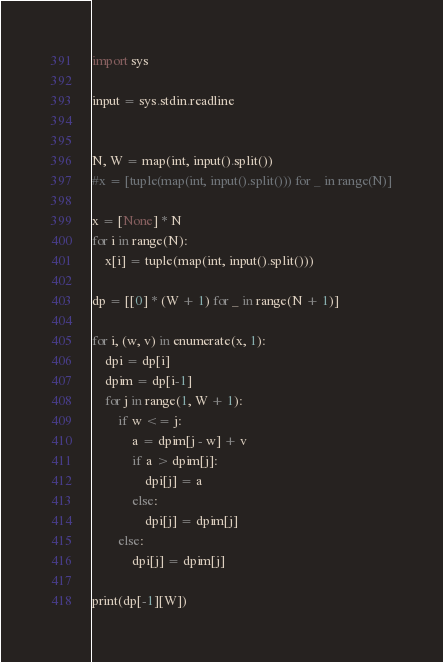<code> <loc_0><loc_0><loc_500><loc_500><_Python_>import sys

input = sys.stdin.readline


N, W = map(int, input().split())
#x = [tuple(map(int, input().split())) for _ in range(N)]

x = [None] * N
for i in range(N):
    x[i] = tuple(map(int, input().split()))
    
dp = [[0] * (W + 1) for _ in range(N + 1)]

for i, (w, v) in enumerate(x, 1):
    dpi = dp[i]
    dpim = dp[i-1]    
    for j in range(1, W + 1):
        if w <= j:
            a = dpim[j - w] + v
            if a > dpim[j]:
                dpi[j] = a
            else:
                dpi[j] = dpim[j]
        else:
            dpi[j] = dpim[j]

print(dp[-1][W])</code> 